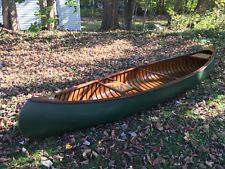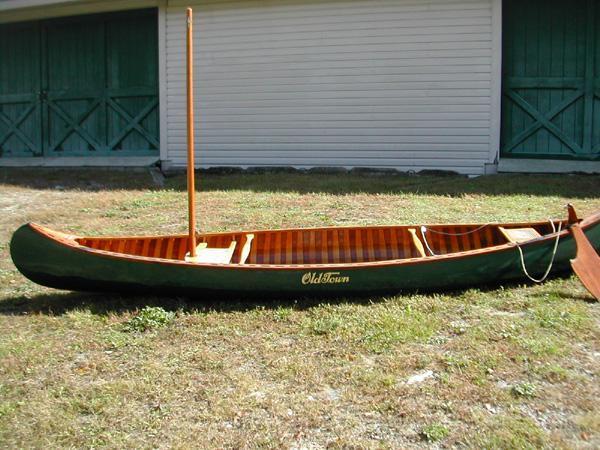The first image is the image on the left, the second image is the image on the right. Considering the images on both sides, is "Both canoes are outside and on dry land." valid? Answer yes or no. Yes. The first image is the image on the left, the second image is the image on the right. Examine the images to the left and right. Is the description "The right image shows a green canoe lying on grass." accurate? Answer yes or no. Yes. 